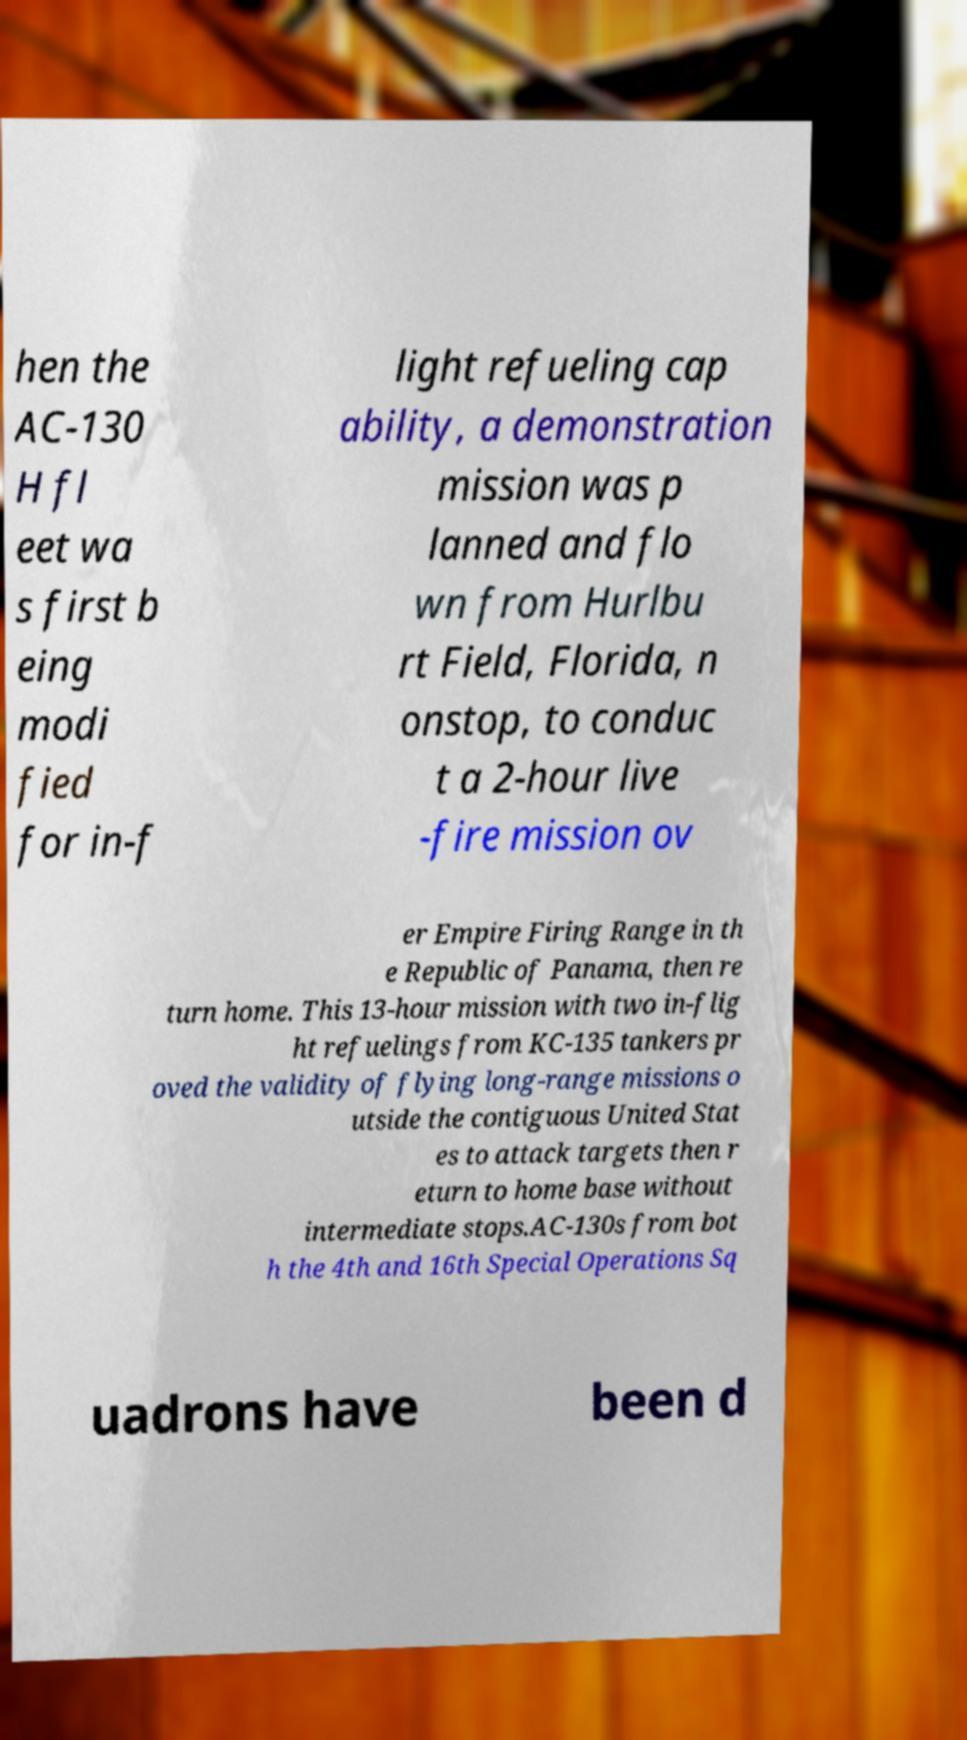Please read and relay the text visible in this image. What does it say? hen the AC-130 H fl eet wa s first b eing modi fied for in-f light refueling cap ability, a demonstration mission was p lanned and flo wn from Hurlbu rt Field, Florida, n onstop, to conduc t a 2-hour live -fire mission ov er Empire Firing Range in th e Republic of Panama, then re turn home. This 13-hour mission with two in-flig ht refuelings from KC-135 tankers pr oved the validity of flying long-range missions o utside the contiguous United Stat es to attack targets then r eturn to home base without intermediate stops.AC-130s from bot h the 4th and 16th Special Operations Sq uadrons have been d 